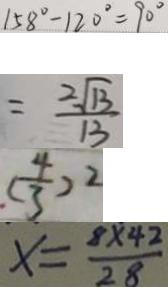Convert formula to latex. <formula><loc_0><loc_0><loc_500><loc_500>1 5 8 ^ { \circ } - 1 2 0 ^ { \circ } = 9 0 ^ { \circ } 
 = \frac { 2 \sqrt { 1 3 } } { 1 3 } 
 ( \frac { 4 } { 3 } ) ^ { 2 } 
 x = \frac { 8 \times 4 2 } { 2 8 }</formula> 